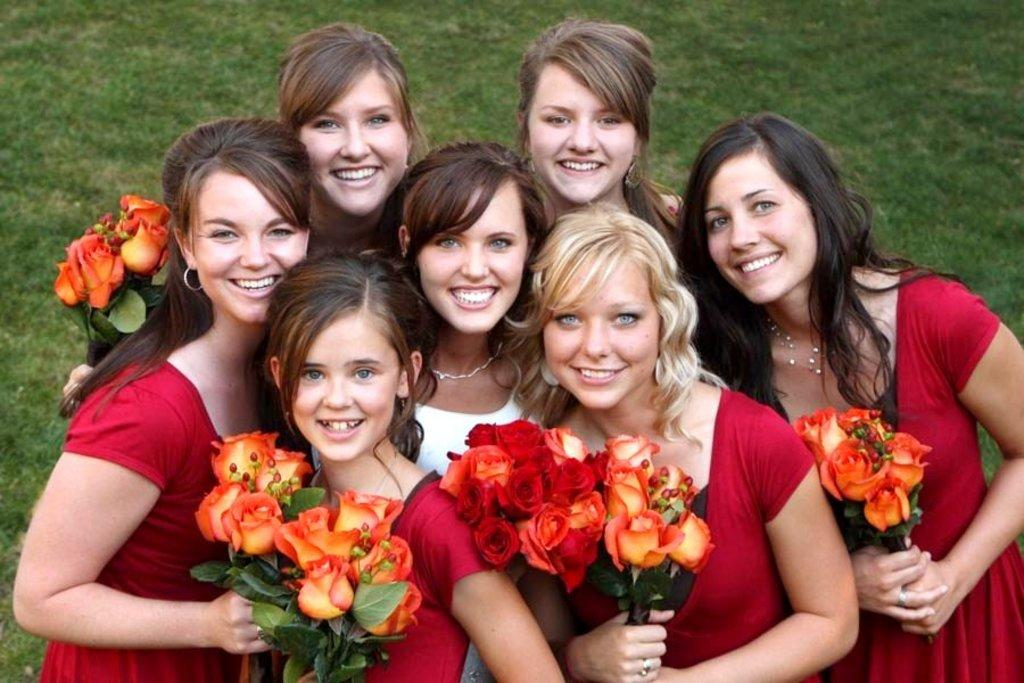What is the main subject of the image? The main subject of the image is a group of girls. What are the girls holding in the image? The girls are holding flowers in the image. What type of natural environment can be seen in the background of the image? There is grass visible in the background of the image. What type of beginner's tool is being used by the girls in the image? There is no tool visible in the image, and the girls are not using any tools; they are holding flowers. 